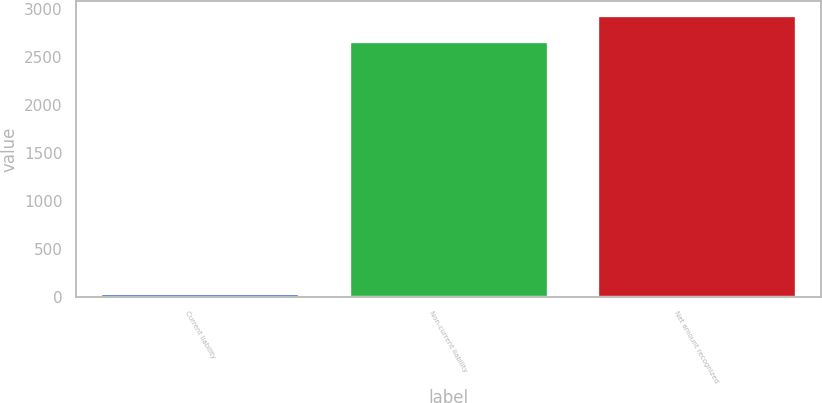Convert chart to OTSL. <chart><loc_0><loc_0><loc_500><loc_500><bar_chart><fcel>Current liability<fcel>Non-current liability<fcel>Net amount recognized<nl><fcel>33<fcel>2668<fcel>2934.8<nl></chart> 